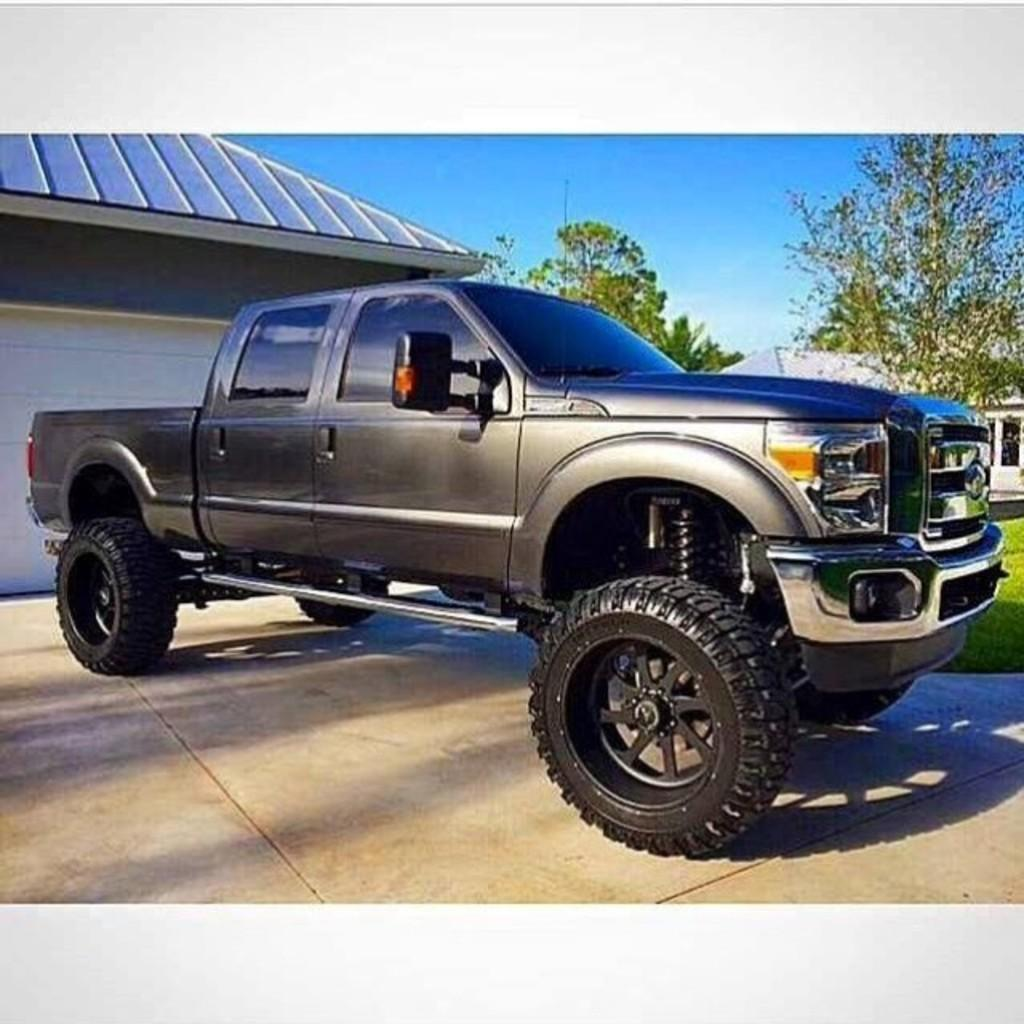What is the main subject in the center of the image? There is a vehicle on the road in the center of the image. What can be seen in the background of the image? There are sheds and trees visible in the background of the image. What is visible at the top of the image? The sky is visible at the top of the image. What type of glove is the porter wearing while handling the plastic in the image? There is no glove, porter, or plastic present in the image. 